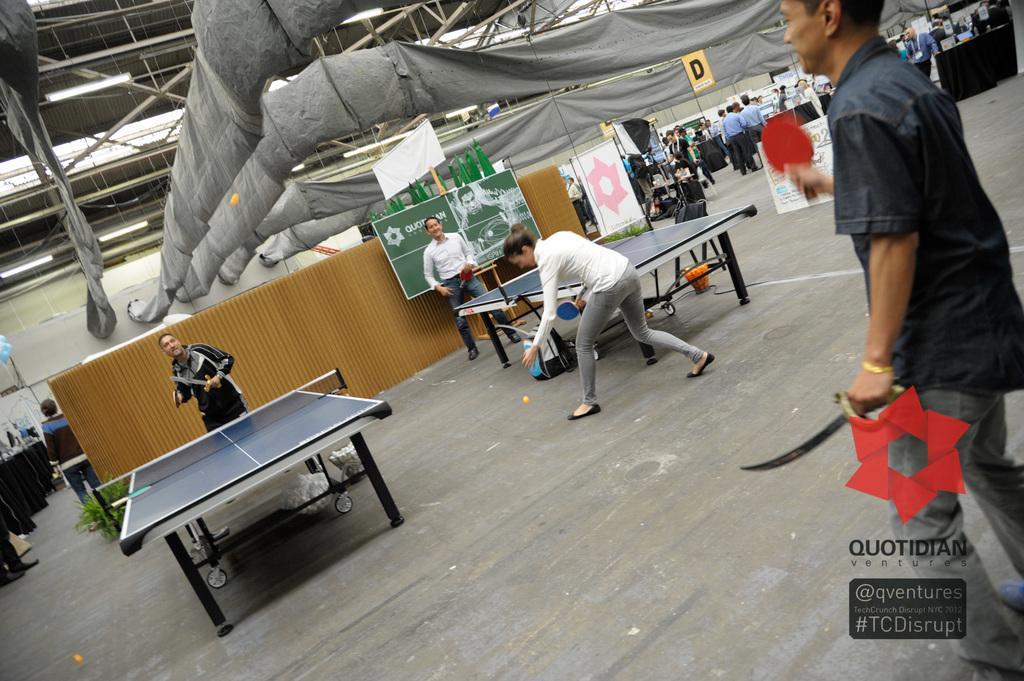Describe this image in one or two sentences. In this image In the middle there are two people playing table tennis game. On the right there is a man he wear shirt and trouser he is holding bat and sword. On the left there is a man he is holding a bat. In the background there are many people and poster. 